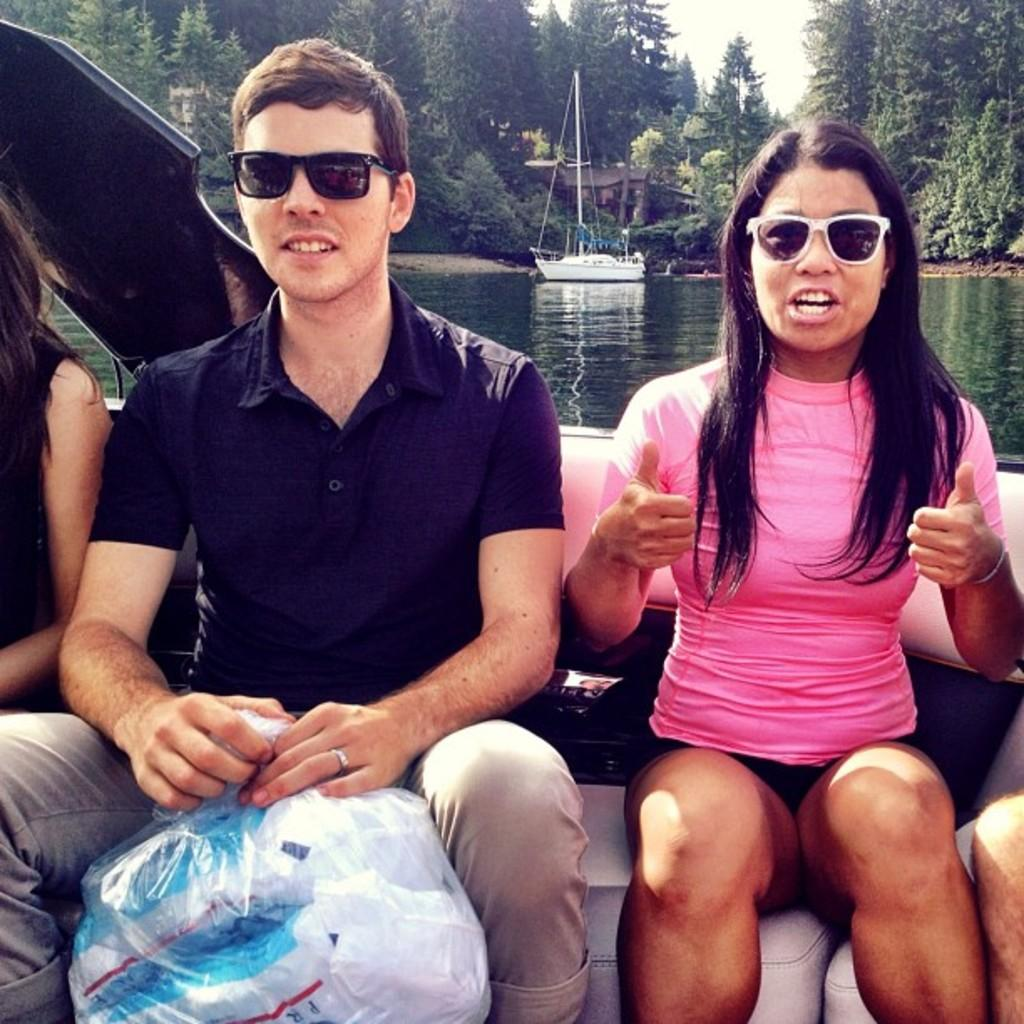What are the people in the image doing? The people in the image are sitting on a boat. Can you describe the setting of the image? There is a boat visible on water in the background of the image, along with trees and the sky. What can be seen in the background of the image? In the background of the image, there are trees and the sky. What type of show is being performed on the boat in the image? There is no show being performed on the boat in the image; it simply shows people sitting on a boat. Can you tell me how many carriages are present in the image? There are no carriages present in the image; it features a boat on water. 